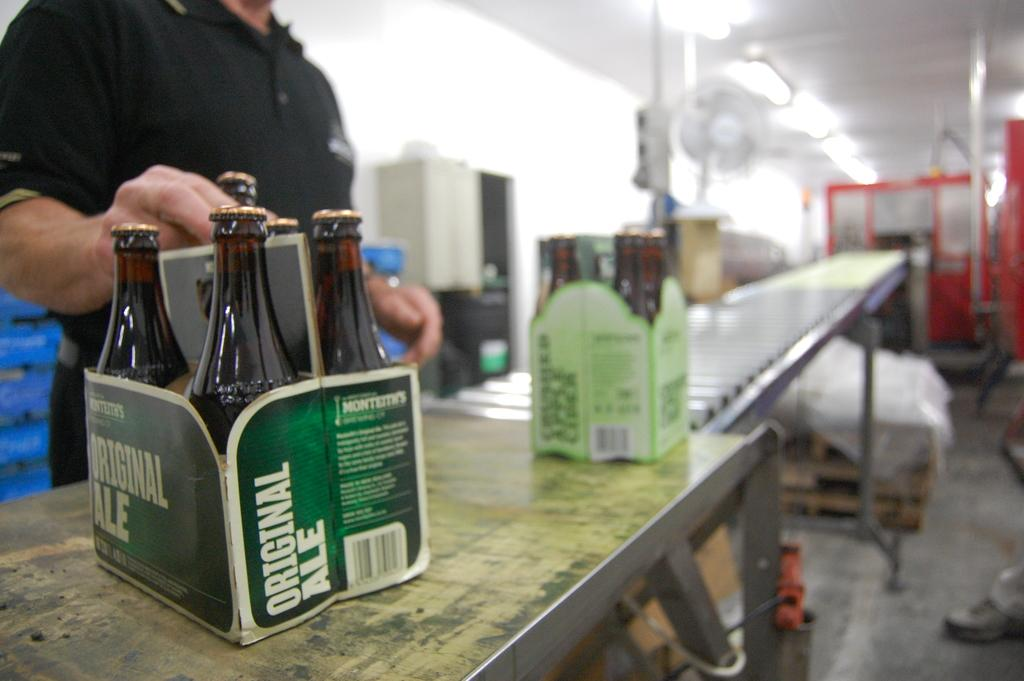Provide a one-sentence caption for the provided image. A 6-pack of original ale is sitting on the counter in a green box. 